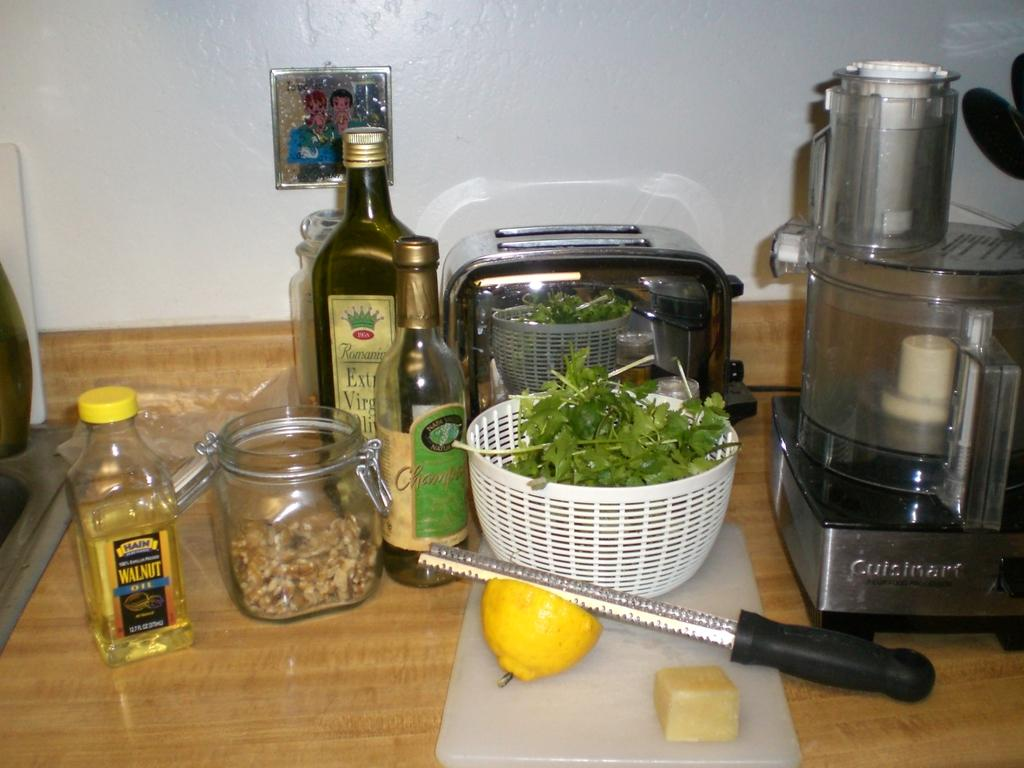<image>
Offer a succinct explanation of the picture presented. Hain Walnut oil and Romaine Extra Virgin oil can be seen on this table. 